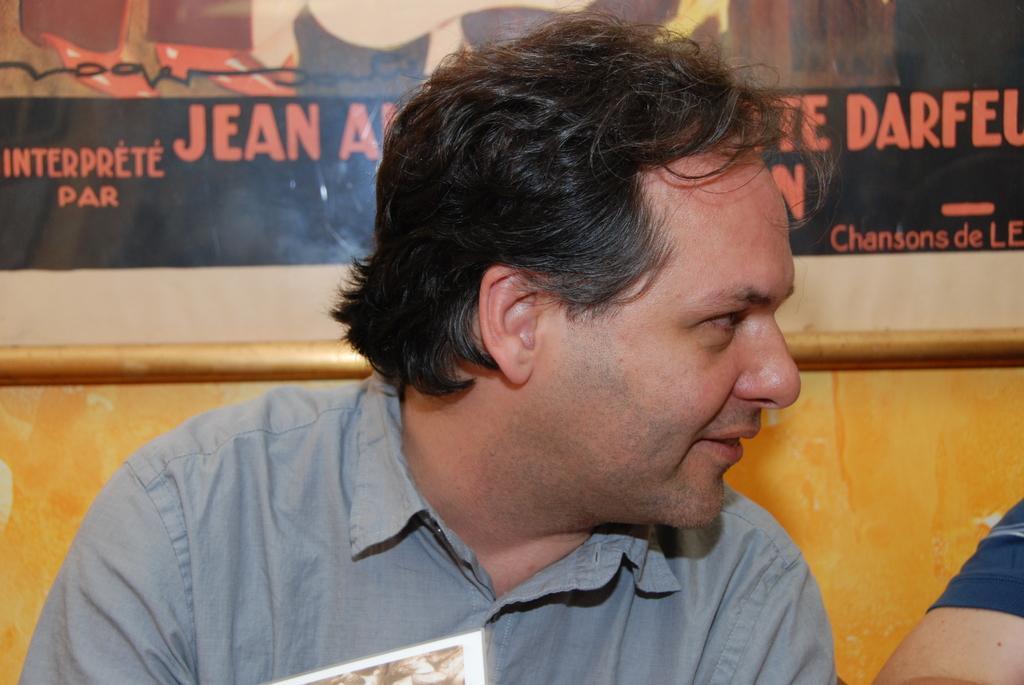In one or two sentences, can you explain what this image depicts? In the picture we can see a man sitting and turning right side and smiling and beside him we can see another person hand and behind the man we can see a wall with a poster and something written on it. 